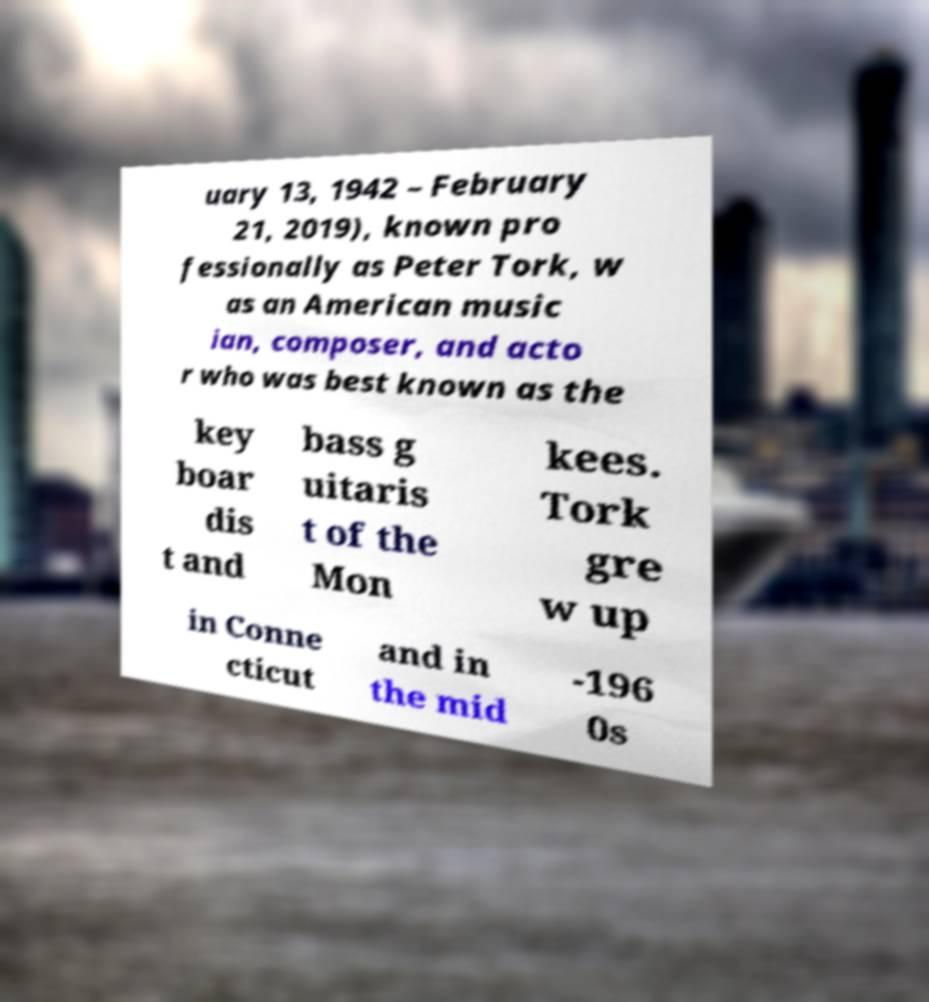I need the written content from this picture converted into text. Can you do that? uary 13, 1942 – February 21, 2019), known pro fessionally as Peter Tork, w as an American music ian, composer, and acto r who was best known as the key boar dis t and bass g uitaris t of the Mon kees. Tork gre w up in Conne cticut and in the mid -196 0s 